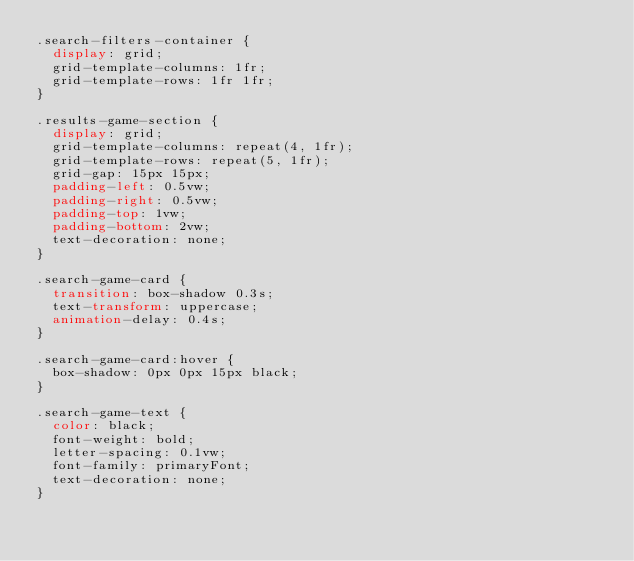<code> <loc_0><loc_0><loc_500><loc_500><_CSS_>.search-filters-container {
  display: grid;
  grid-template-columns: 1fr;
  grid-template-rows: 1fr 1fr;
}

.results-game-section {
  display: grid;
  grid-template-columns: repeat(4, 1fr);
  grid-template-rows: repeat(5, 1fr);
  grid-gap: 15px 15px;
  padding-left: 0.5vw;
  padding-right: 0.5vw;
  padding-top: 1vw;
  padding-bottom: 2vw;
  text-decoration: none;
}

.search-game-card {
  transition: box-shadow 0.3s;
  text-transform: uppercase;
  animation-delay: 0.4s;
}

.search-game-card:hover {
  box-shadow: 0px 0px 15px black;
}

.search-game-text {
  color: black;
  font-weight: bold;
  letter-spacing: 0.1vw;
  font-family: primaryFont;
  text-decoration: none;
}</code> 